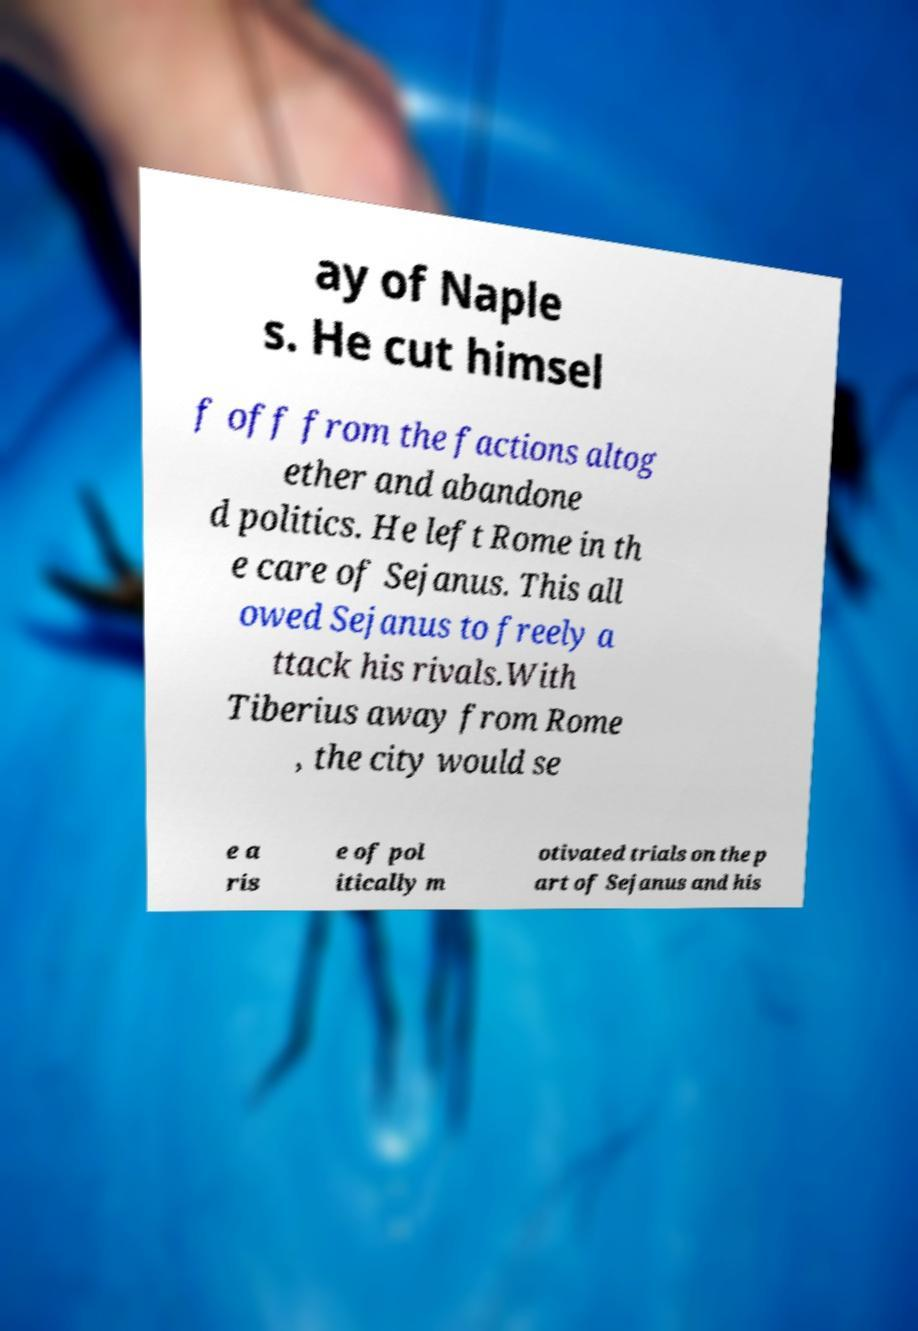Could you extract and type out the text from this image? ay of Naple s. He cut himsel f off from the factions altog ether and abandone d politics. He left Rome in th e care of Sejanus. This all owed Sejanus to freely a ttack his rivals.With Tiberius away from Rome , the city would se e a ris e of pol itically m otivated trials on the p art of Sejanus and his 